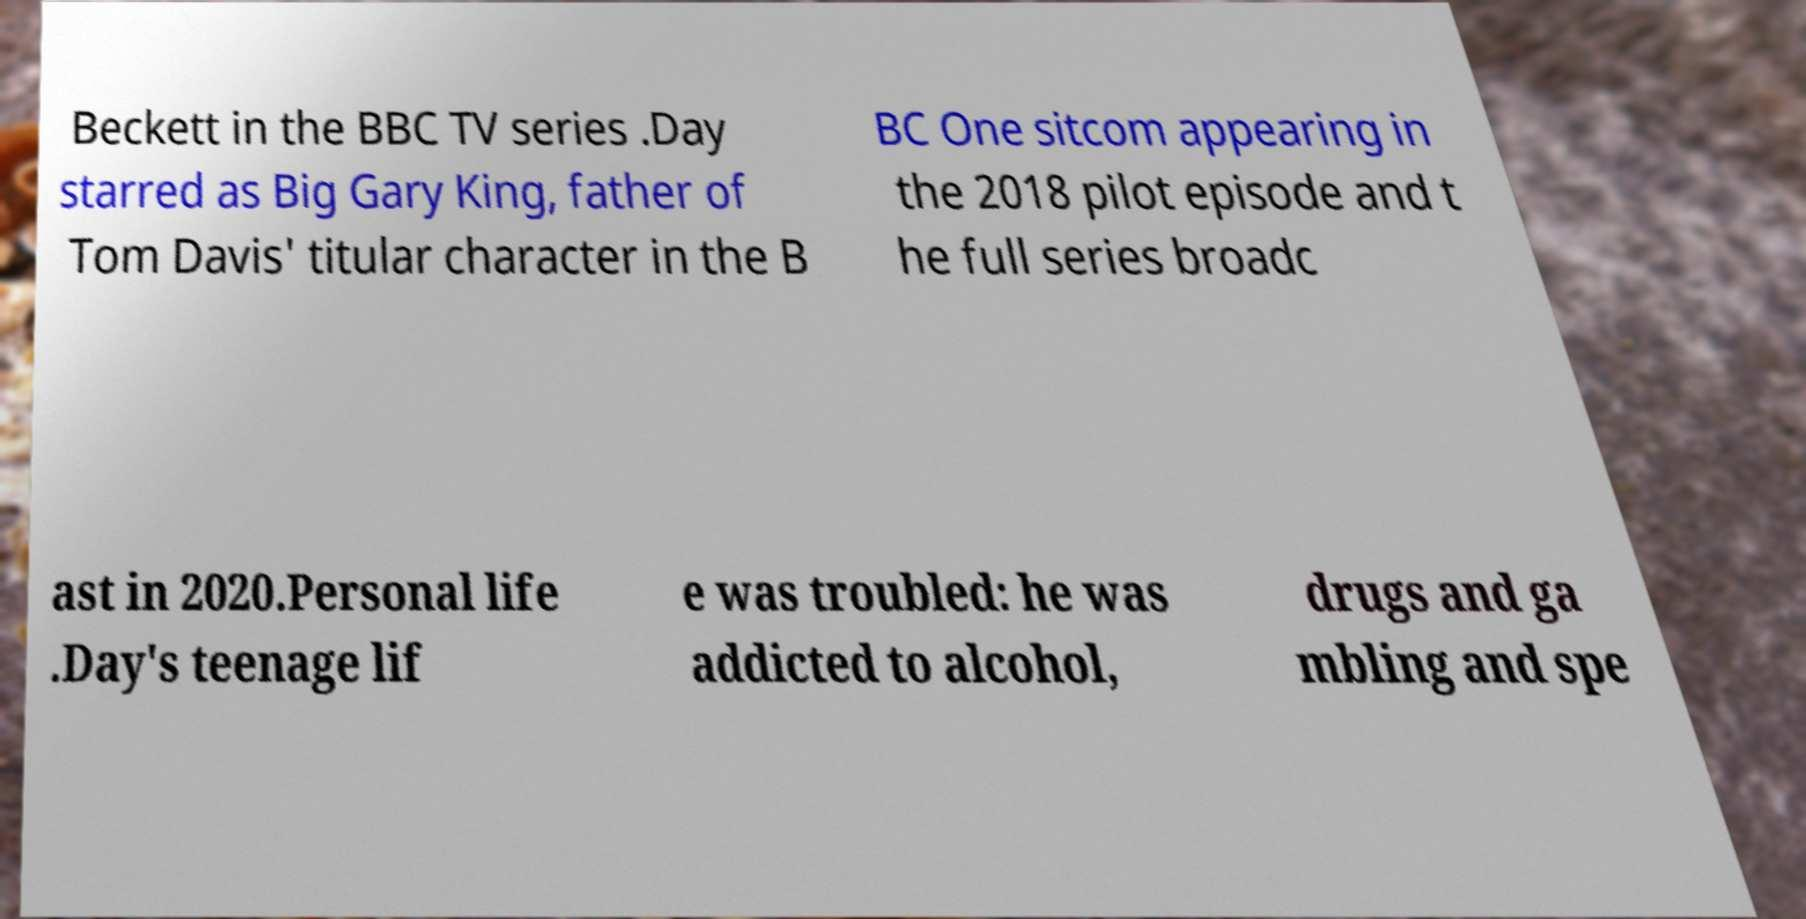Could you extract and type out the text from this image? Beckett in the BBC TV series .Day starred as Big Gary King, father of Tom Davis' titular character in the B BC One sitcom appearing in the 2018 pilot episode and t he full series broadc ast in 2020.Personal life .Day's teenage lif e was troubled: he was addicted to alcohol, drugs and ga mbling and spe 